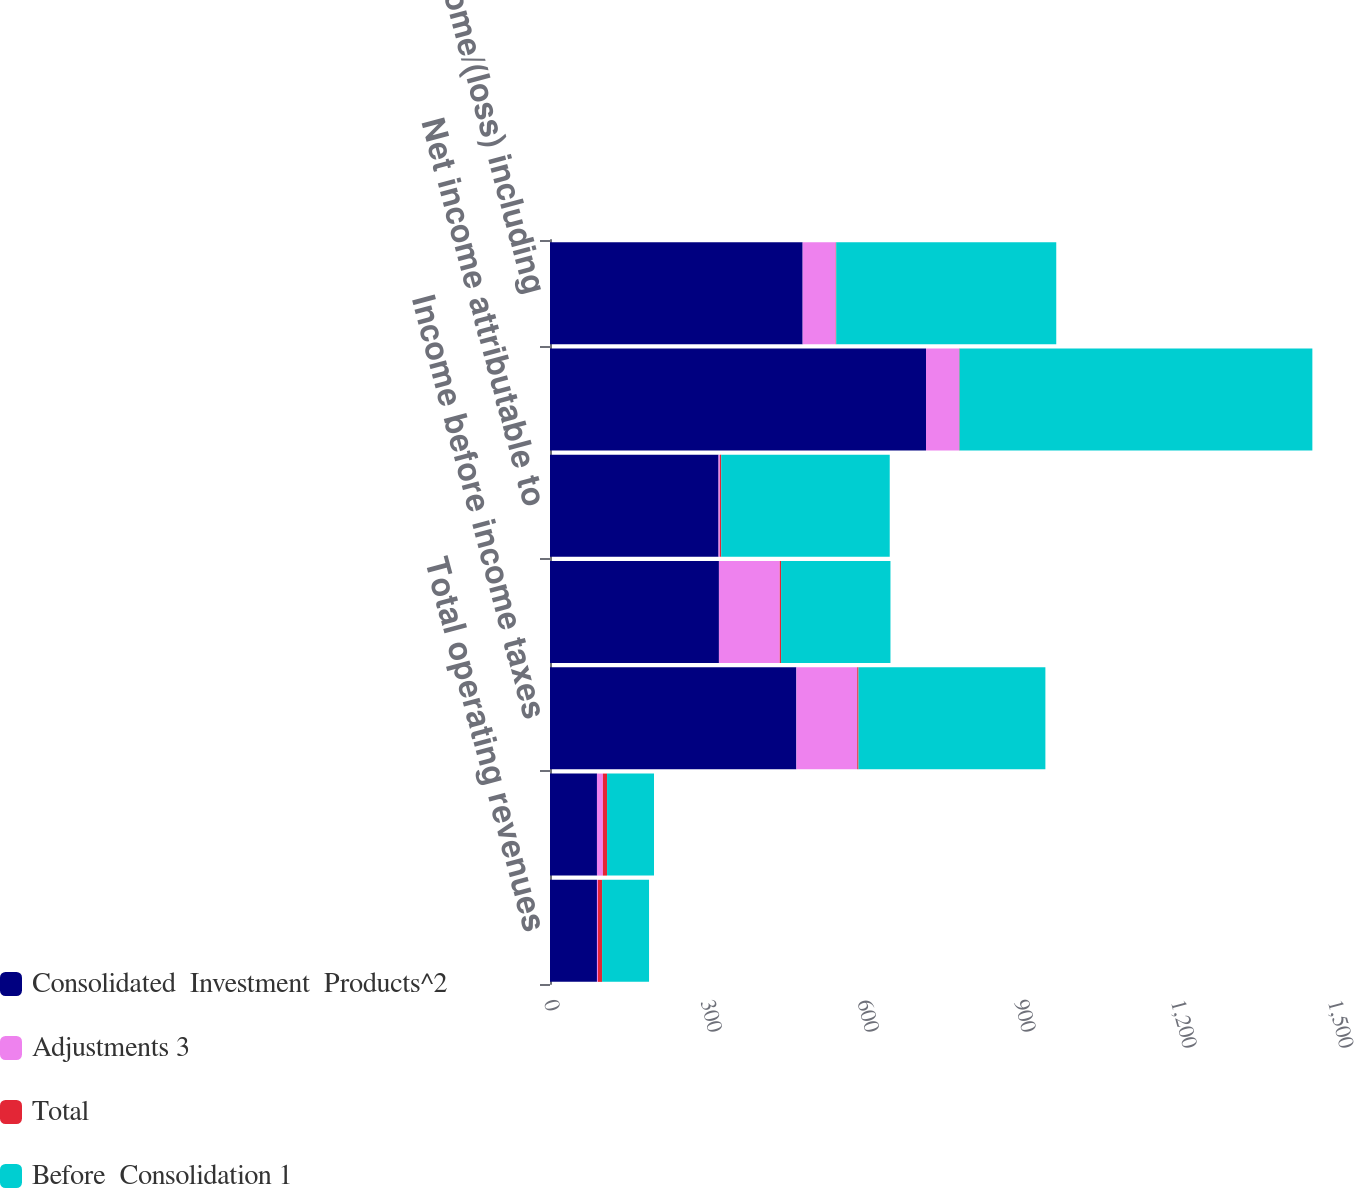Convert chart to OTSL. <chart><loc_0><loc_0><loc_500><loc_500><stacked_bar_chart><ecel><fcel>Total operating revenues<fcel>Total operating expenses<fcel>Income before income taxes<fcel>Net income including gains and<fcel>Net income attributable to<fcel>Income/(loss) before income<fcel>Net income/(loss) including<nl><fcel>Consolidated  Investment  Products^2<fcel>89.85<fcel>89.85<fcel>471.4<fcel>323.2<fcel>322.5<fcel>719.4<fcel>483.4<nl><fcel>Adjustments 3<fcel>1.9<fcel>11.4<fcel>116.4<fcel>116.4<fcel>2.5<fcel>63.3<fcel>63.3<nl><fcel>Total<fcel>7.9<fcel>7.9<fcel>2.5<fcel>2.5<fcel>2.5<fcel>0.9<fcel>0.9<nl><fcel>Before  Consolidation 1<fcel>89.85<fcel>89.85<fcel>357.5<fcel>209.3<fcel>322.5<fcel>675<fcel>421<nl></chart> 